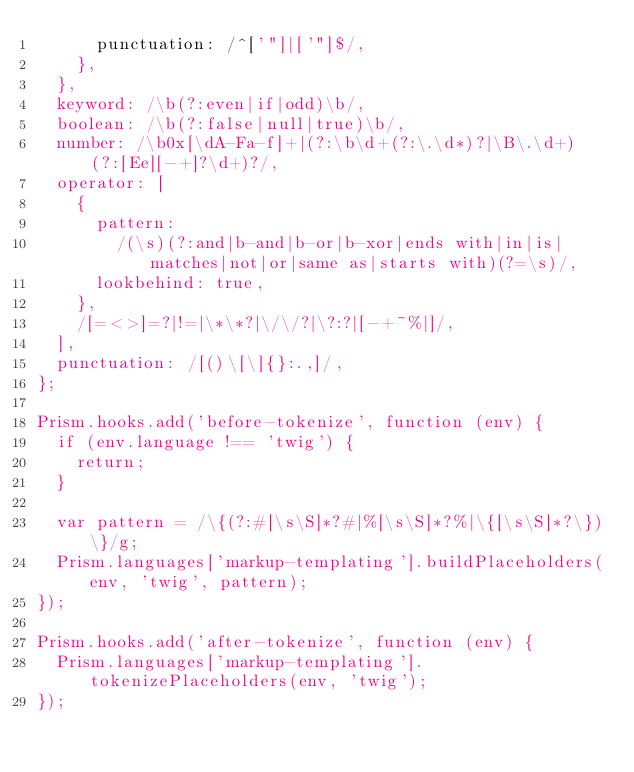Convert code to text. <code><loc_0><loc_0><loc_500><loc_500><_JavaScript_>      punctuation: /^['"]|['"]$/,
    },
  },
  keyword: /\b(?:even|if|odd)\b/,
  boolean: /\b(?:false|null|true)\b/,
  number: /\b0x[\dA-Fa-f]+|(?:\b\d+(?:\.\d*)?|\B\.\d+)(?:[Ee][-+]?\d+)?/,
  operator: [
    {
      pattern:
        /(\s)(?:and|b-and|b-or|b-xor|ends with|in|is|matches|not|or|same as|starts with)(?=\s)/,
      lookbehind: true,
    },
    /[=<>]=?|!=|\*\*?|\/\/?|\?:?|[-+~%|]/,
  ],
  punctuation: /[()\[\]{}:.,]/,
};

Prism.hooks.add('before-tokenize', function (env) {
  if (env.language !== 'twig') {
    return;
  }

  var pattern = /\{(?:#[\s\S]*?#|%[\s\S]*?%|\{[\s\S]*?\})\}/g;
  Prism.languages['markup-templating'].buildPlaceholders(env, 'twig', pattern);
});

Prism.hooks.add('after-tokenize', function (env) {
  Prism.languages['markup-templating'].tokenizePlaceholders(env, 'twig');
});
</code> 